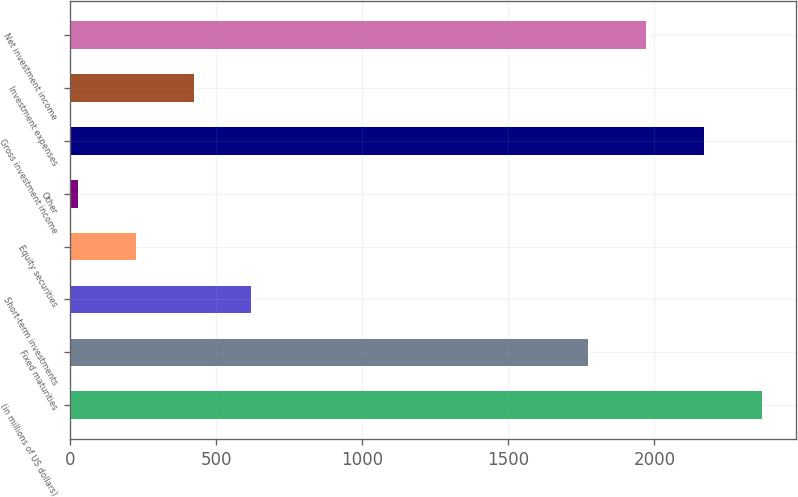<chart> <loc_0><loc_0><loc_500><loc_500><bar_chart><fcel>(in millions of US dollars)<fcel>Fixed maturities<fcel>Short-term investments<fcel>Equity securities<fcel>Other<fcel>Gross investment income<fcel>Investment expenses<fcel>Net investment income<nl><fcel>2367.6<fcel>1773<fcel>619.6<fcel>223.2<fcel>25<fcel>2169.4<fcel>421.4<fcel>1971.2<nl></chart> 